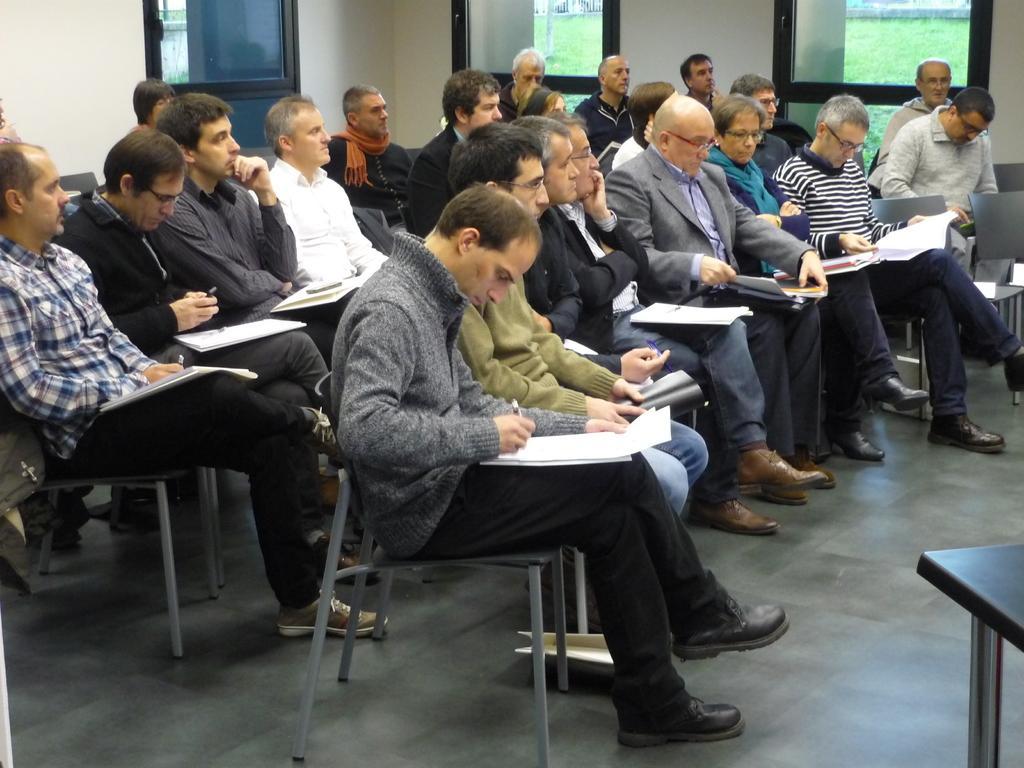Describe this image in one or two sentences. Every person is sitting on a chair. Every person holds a paper and book. This person is writing on a paper. This is a window. The grass is in green color. 